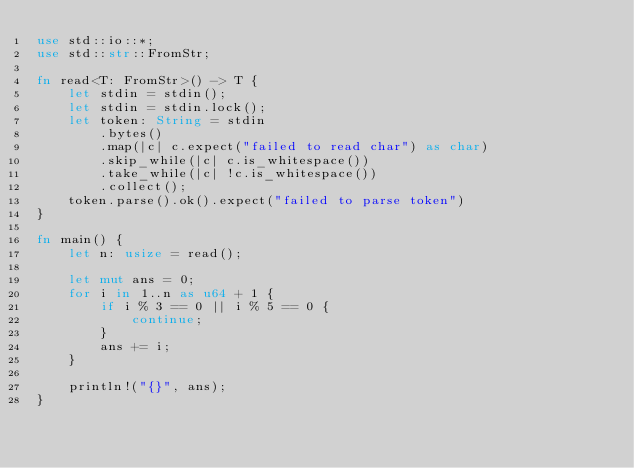<code> <loc_0><loc_0><loc_500><loc_500><_Rust_>use std::io::*;
use std::str::FromStr;

fn read<T: FromStr>() -> T {
    let stdin = stdin();
    let stdin = stdin.lock();
    let token: String = stdin
        .bytes()
        .map(|c| c.expect("failed to read char") as char) 
        .skip_while(|c| c.is_whitespace())
        .take_while(|c| !c.is_whitespace())
        .collect();
    token.parse().ok().expect("failed to parse token")
}

fn main() {
    let n: usize = read();

    let mut ans = 0;
    for i in 1..n as u64 + 1 {
        if i % 3 == 0 || i % 5 == 0 {
            continue;
        }
        ans += i;
    }

    println!("{}", ans);
}
</code> 